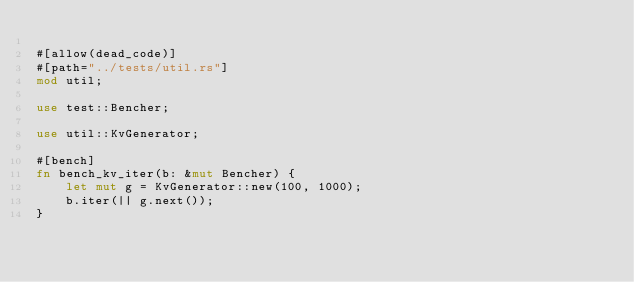<code> <loc_0><loc_0><loc_500><loc_500><_Rust_>
#[allow(dead_code)]
#[path="../tests/util.rs"]
mod util;

use test::Bencher;

use util::KvGenerator;

#[bench]
fn bench_kv_iter(b: &mut Bencher) {
    let mut g = KvGenerator::new(100, 1000);
    b.iter(|| g.next());
}
</code> 